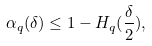<formula> <loc_0><loc_0><loc_500><loc_500>\alpha _ { q } ( \delta ) \leq 1 - H _ { q } ( \frac { \delta } { 2 } ) ,</formula> 